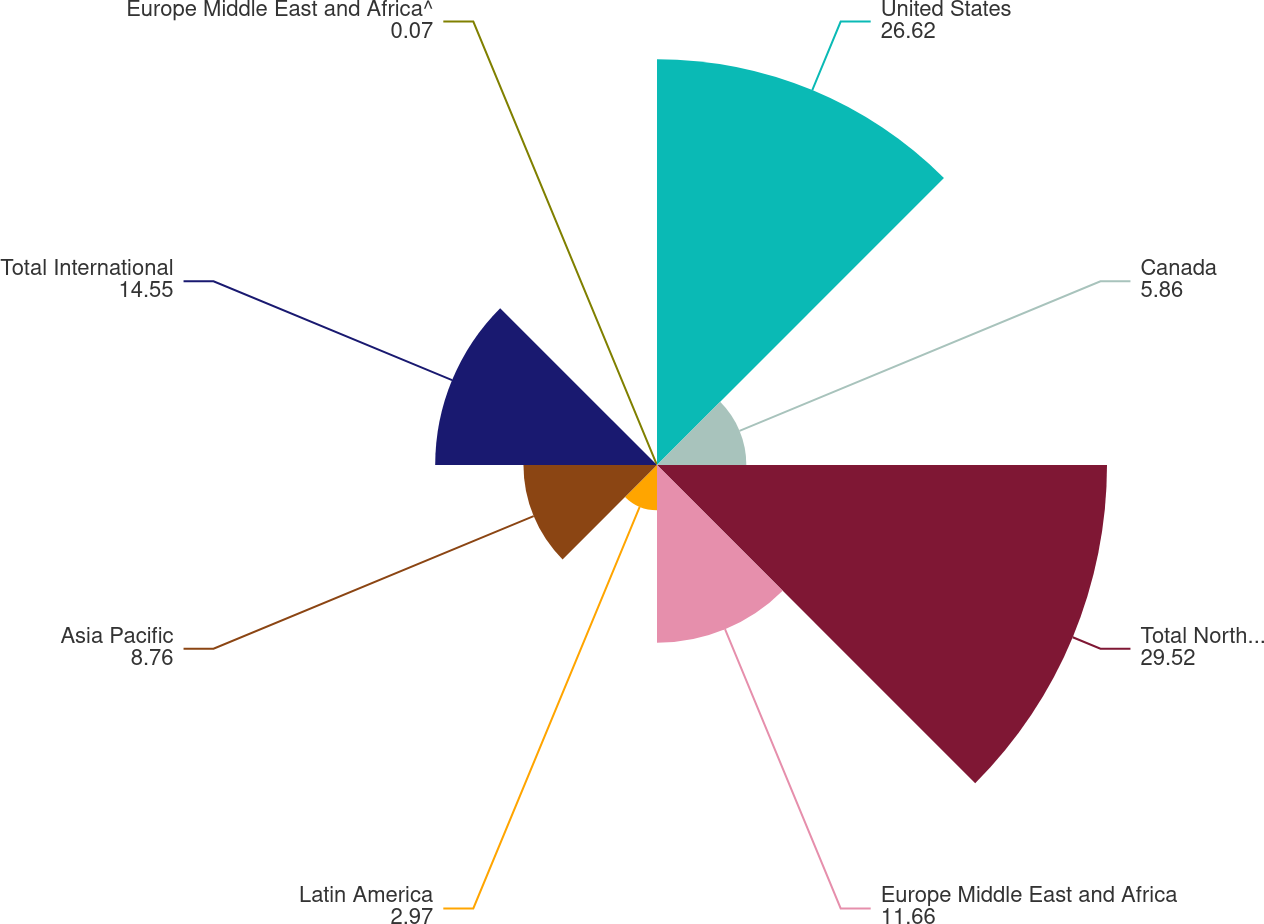<chart> <loc_0><loc_0><loc_500><loc_500><pie_chart><fcel>United States<fcel>Canada<fcel>Total North America<fcel>Europe Middle East and Africa<fcel>Latin America<fcel>Asia Pacific<fcel>Total International<fcel>Europe Middle East and Africa^<nl><fcel>26.62%<fcel>5.86%<fcel>29.52%<fcel>11.66%<fcel>2.97%<fcel>8.76%<fcel>14.55%<fcel>0.07%<nl></chart> 